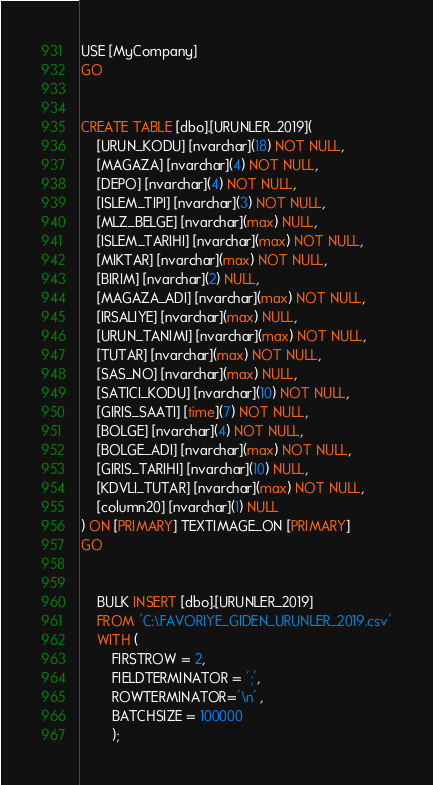<code> <loc_0><loc_0><loc_500><loc_500><_SQL_>USE [MyCompany]
GO


CREATE TABLE [dbo].[URUNLER_2019](
	[URUN_KODU] [nvarchar](18) NOT NULL,
	[MAGAZA] [nvarchar](4) NOT NULL,
	[DEPO] [nvarchar](4) NOT NULL,
	[ISLEM_TIPI] [nvarchar](3) NOT NULL,
	[MLZ_BELGE] [nvarchar](max) NULL,
	[ISLEM_TARIHI] [nvarchar](max) NOT NULL,
	[MIKTAR] [nvarchar](max) NOT NULL,
	[BIRIM] [nvarchar](2) NULL,
	[MAGAZA_ADI] [nvarchar](max) NOT NULL,
	[IRSALIYE] [nvarchar](max) NULL,
	[URUN_TANIMI] [nvarchar](max) NOT NULL,
	[TUTAR] [nvarchar](max) NOT NULL,
	[SAS_NO] [nvarchar](max) NULL,
	[SATICI_KODU] [nvarchar](10) NOT NULL,
	[GIRIS_SAATI] [time](7) NOT NULL,
	[BOLGE] [nvarchar](4) NOT NULL,
	[BOLGE_ADI] [nvarchar](max) NOT NULL,
	[GIRIS_TARIHI] [nvarchar](10) NULL,
	[KDVLI_TUTAR] [nvarchar](max) NOT NULL,
	[column20] [nvarchar](1) NULL
) ON [PRIMARY] TEXTIMAGE_ON [PRIMARY]
GO


	BULK INSERT [dbo].[URUNLER_2019]
	FROM 'C:\FAVORIYE_GIDEN_URUNLER_2019.csv'
	WITH (
		FIRSTROW = 2,
		FIELDTERMINATOR = ';',
		ROWTERMINATOR='\n' ,
		BATCHSIZE = 100000
		);
</code> 